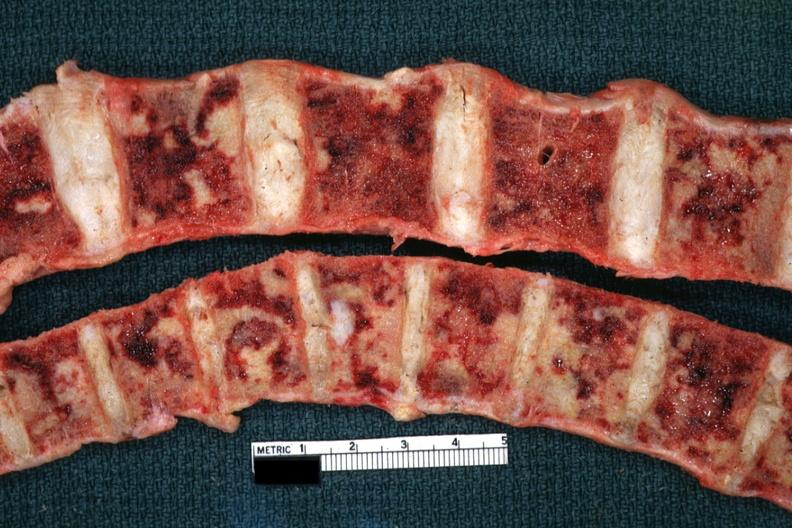s joints present?
Answer the question using a single word or phrase. Yes 